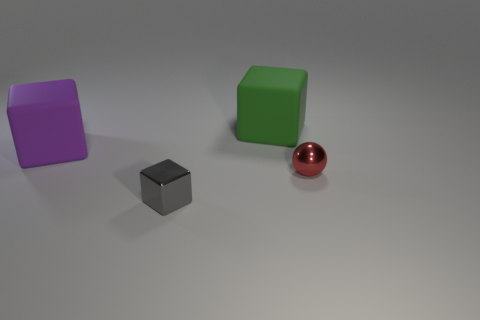Add 1 yellow spheres. How many objects exist? 5 Subtract all balls. How many objects are left? 3 Add 3 small blue matte cylinders. How many small blue matte cylinders exist? 3 Subtract 1 purple cubes. How many objects are left? 3 Subtract all big purple matte objects. Subtract all tiny metallic balls. How many objects are left? 2 Add 3 large green matte things. How many large green matte things are left? 4 